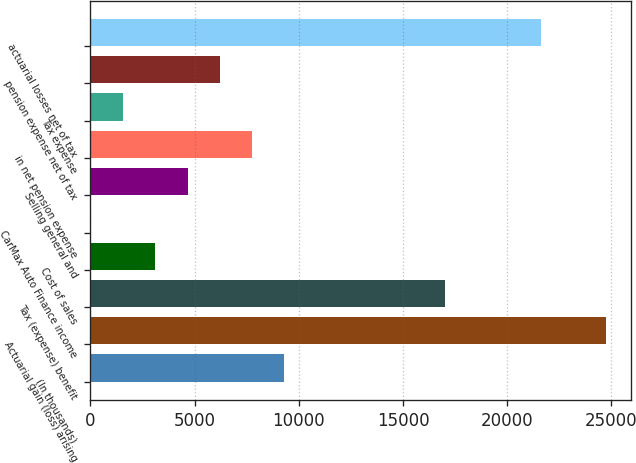Convert chart to OTSL. <chart><loc_0><loc_0><loc_500><loc_500><bar_chart><fcel>(In thousands)<fcel>Actuarial gain (loss) arising<fcel>Tax (expense) benefit<fcel>Cost of sales<fcel>CarMax Auto Finance income<fcel>Selling general and<fcel>in net pension expense<fcel>Tax expense<fcel>pension expense net of tax<fcel>actuarial losses net of tax<nl><fcel>9294.2<fcel>24721.2<fcel>17007.7<fcel>3123.4<fcel>38<fcel>4666.1<fcel>7751.5<fcel>1580.7<fcel>6208.8<fcel>21635.8<nl></chart> 